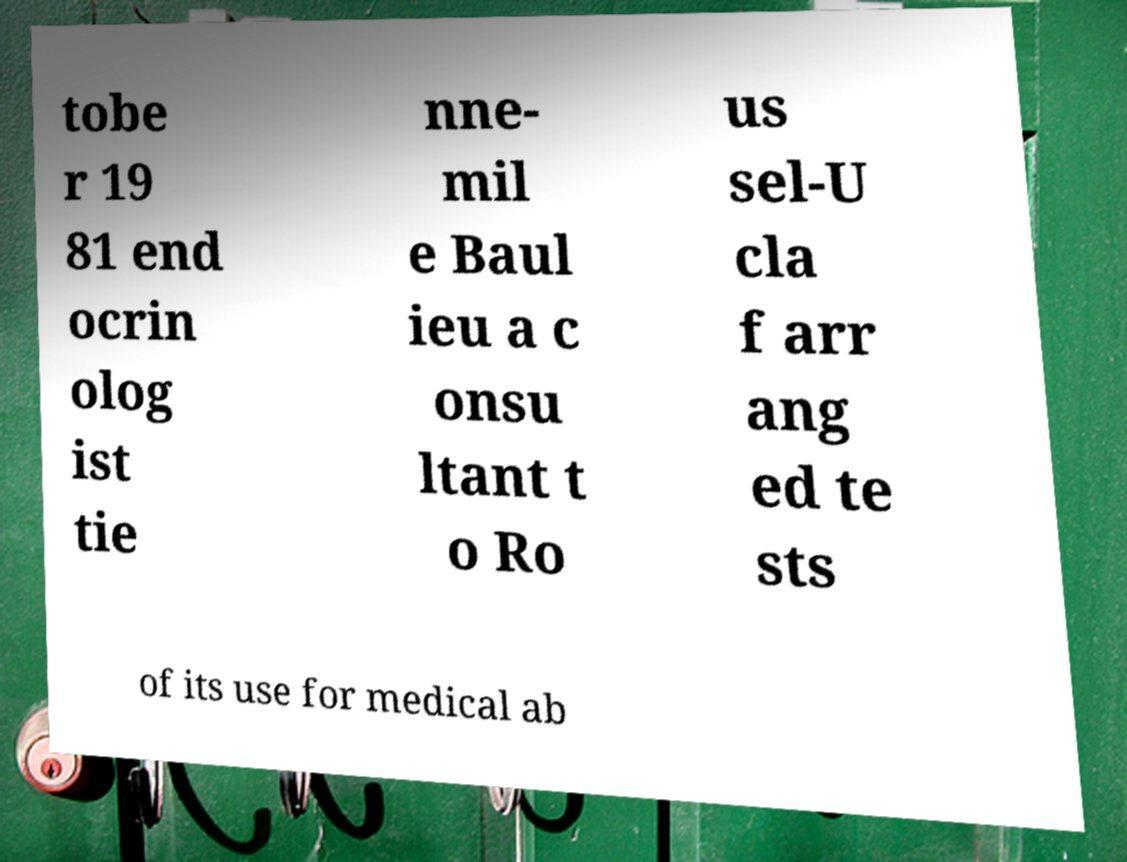Can you read and provide the text displayed in the image?This photo seems to have some interesting text. Can you extract and type it out for me? tobe r 19 81 end ocrin olog ist tie nne- mil e Baul ieu a c onsu ltant t o Ro us sel-U cla f arr ang ed te sts of its use for medical ab 